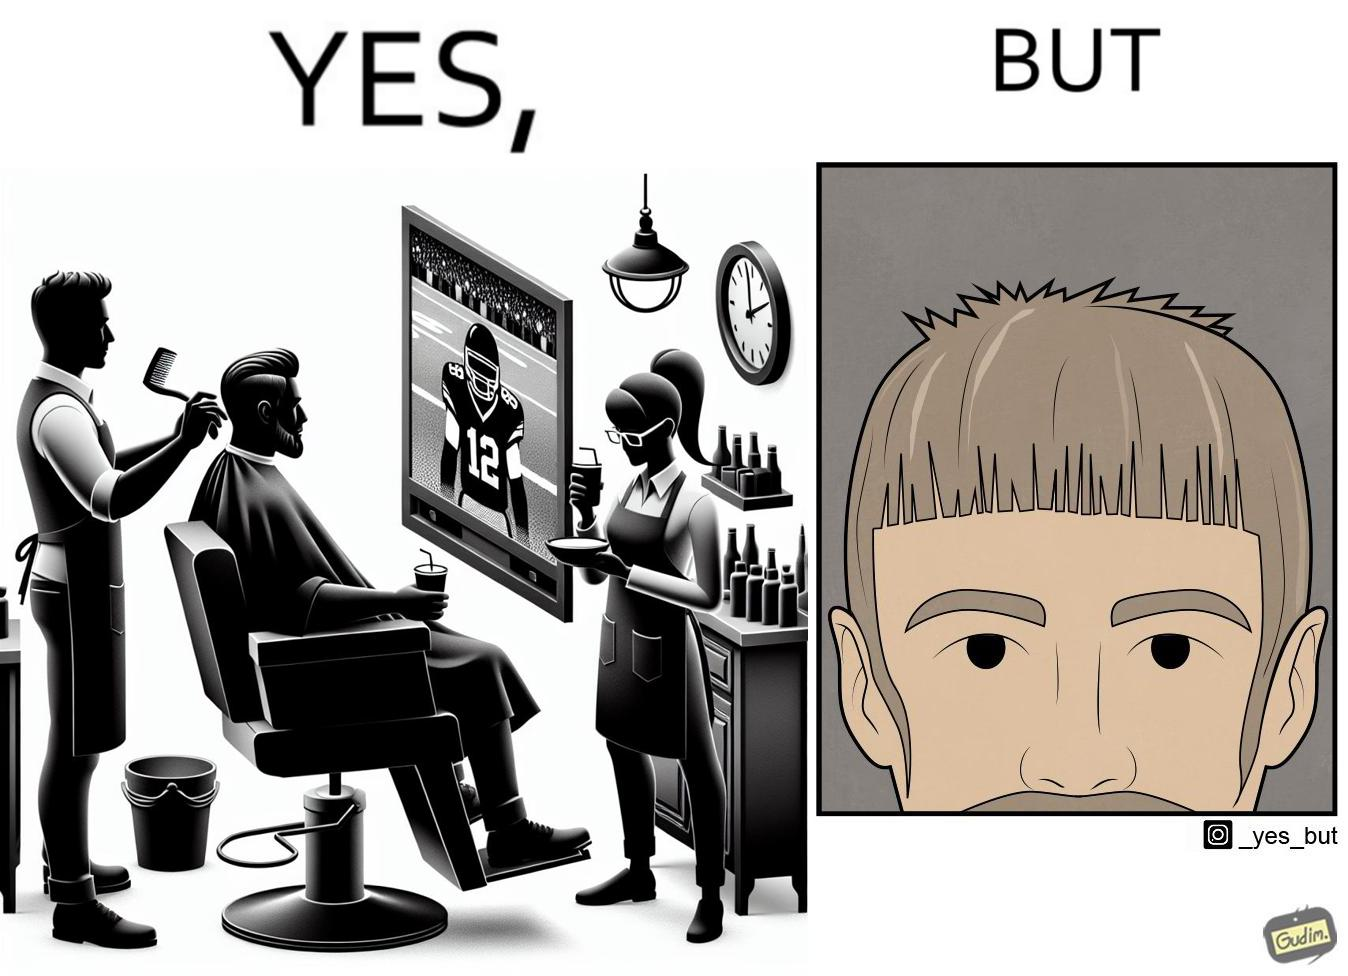What is shown in the left half versus the right half of this image? In the left part of the image: a person at a men's saloon during his hair cut, playing football game on tv and a person serving him some beverage in cup In the right part of the image: a person with an average looking haircut 